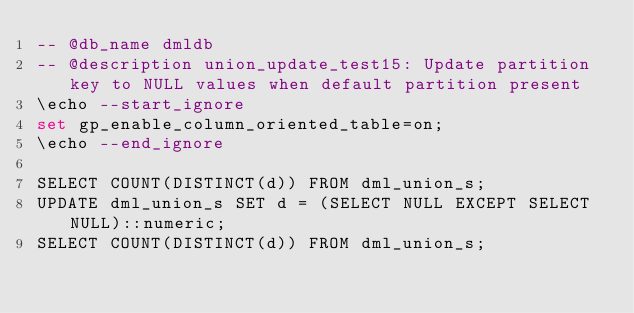<code> <loc_0><loc_0><loc_500><loc_500><_SQL_>-- @db_name dmldb
-- @description union_update_test15: Update partition key to NULL values when default partition present
\echo --start_ignore
set gp_enable_column_oriented_table=on;
\echo --end_ignore

SELECT COUNT(DISTINCT(d)) FROM dml_union_s; 
UPDATE dml_union_s SET d = (SELECT NULL EXCEPT SELECT NULL)::numeric;
SELECT COUNT(DISTINCT(d)) FROM dml_union_s; 
</code> 